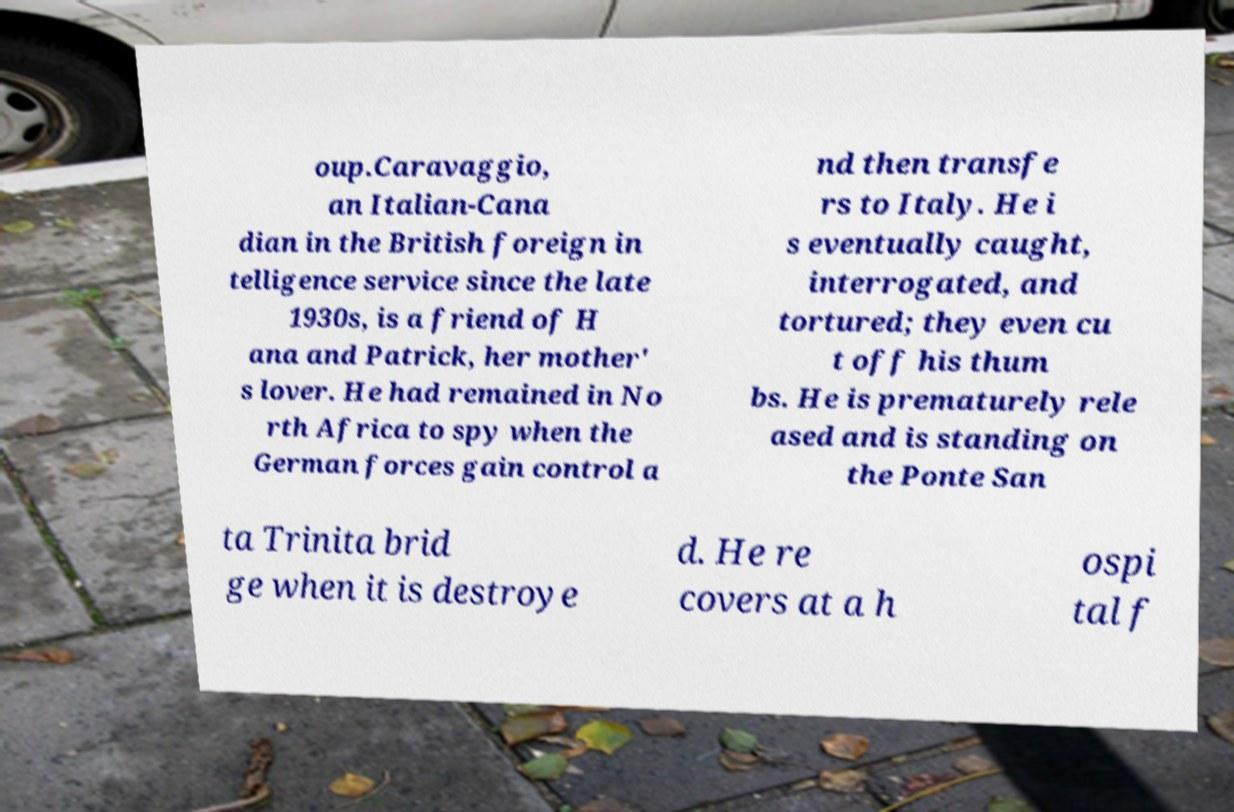Can you read and provide the text displayed in the image?This photo seems to have some interesting text. Can you extract and type it out for me? oup.Caravaggio, an Italian-Cana dian in the British foreign in telligence service since the late 1930s, is a friend of H ana and Patrick, her mother' s lover. He had remained in No rth Africa to spy when the German forces gain control a nd then transfe rs to Italy. He i s eventually caught, interrogated, and tortured; they even cu t off his thum bs. He is prematurely rele ased and is standing on the Ponte San ta Trinita brid ge when it is destroye d. He re covers at a h ospi tal f 